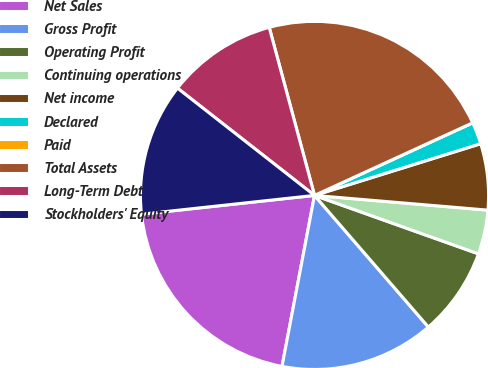Convert chart to OTSL. <chart><loc_0><loc_0><loc_500><loc_500><pie_chart><fcel>Net Sales<fcel>Gross Profit<fcel>Operating Profit<fcel>Continuing operations<fcel>Net income<fcel>Declared<fcel>Paid<fcel>Total Assets<fcel>Long-Term Debt<fcel>Stockholders' Equity<nl><fcel>20.29%<fcel>14.34%<fcel>8.2%<fcel>4.1%<fcel>6.15%<fcel>2.05%<fcel>0.0%<fcel>22.34%<fcel>10.24%<fcel>12.29%<nl></chart> 